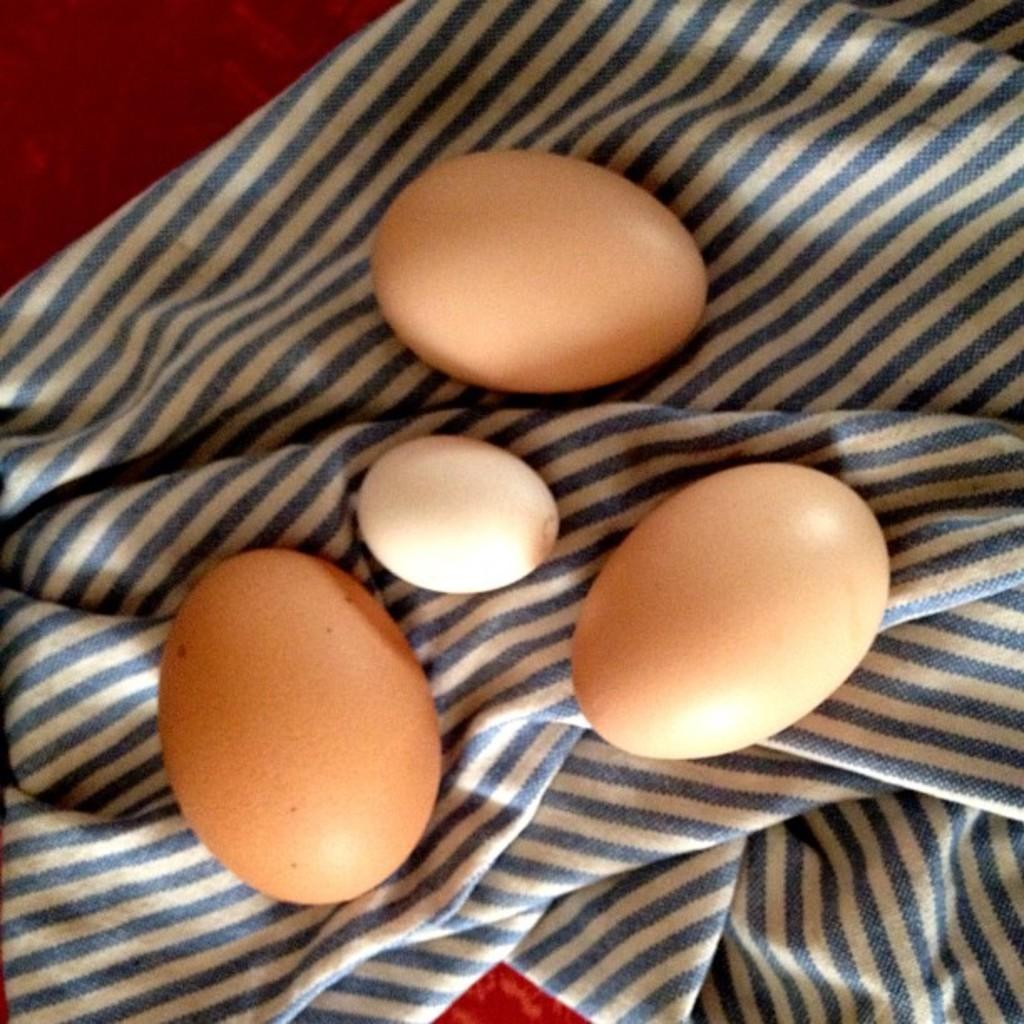Describe this image in one or two sentences. In the image we can see there are four eggs kept on the cloth. 